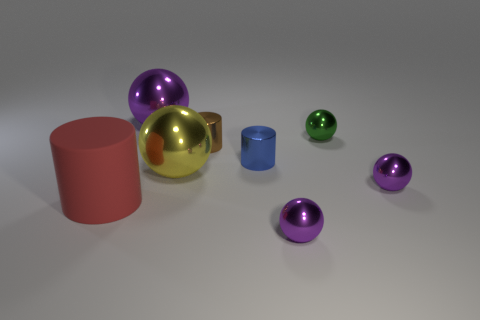Is there a big shiny cube of the same color as the big cylinder?
Keep it short and to the point. No. Is there any other thing that is the same size as the green metallic object?
Your answer should be compact. Yes. How many tiny metal cylinders are the same color as the large cylinder?
Ensure brevity in your answer.  0. Do the rubber cylinder and the tiny metallic cylinder that is right of the brown metal cylinder have the same color?
Give a very brief answer. No. How many objects are small green metallic blocks or large metallic objects behind the small green sphere?
Provide a succinct answer. 1. There is a purple ball that is left of the tiny metallic object in front of the large matte thing; how big is it?
Give a very brief answer. Large. Is the number of large purple objects that are in front of the small brown metal object the same as the number of large cylinders that are in front of the green shiny thing?
Ensure brevity in your answer.  No. There is a thing that is in front of the red matte thing; are there any tiny brown cylinders to the right of it?
Make the answer very short. No. What shape is the brown object that is the same material as the yellow sphere?
Provide a short and direct response. Cylinder. Is there anything else that is the same color as the rubber object?
Provide a succinct answer. No. 